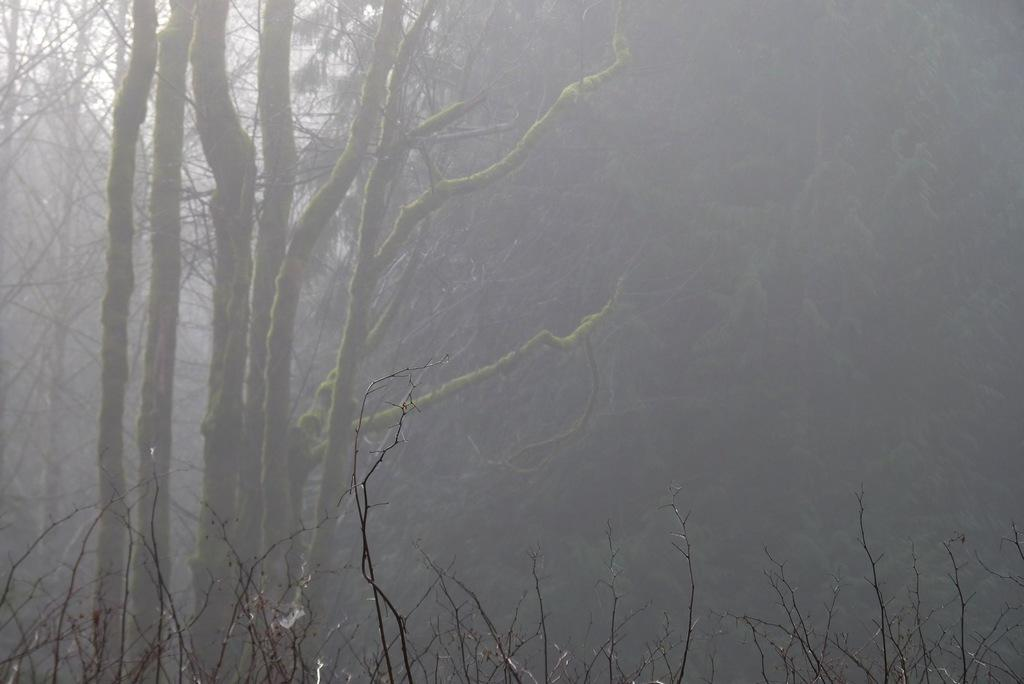What type of fruit is present in the image? There is a fig in the image. What type of vegetation can be seen in the image? There are trees and plants in the image. What color is the scarf that the fig is wearing in the image? There is no scarf present in the image, as figs are fruit and do not wear clothing. 